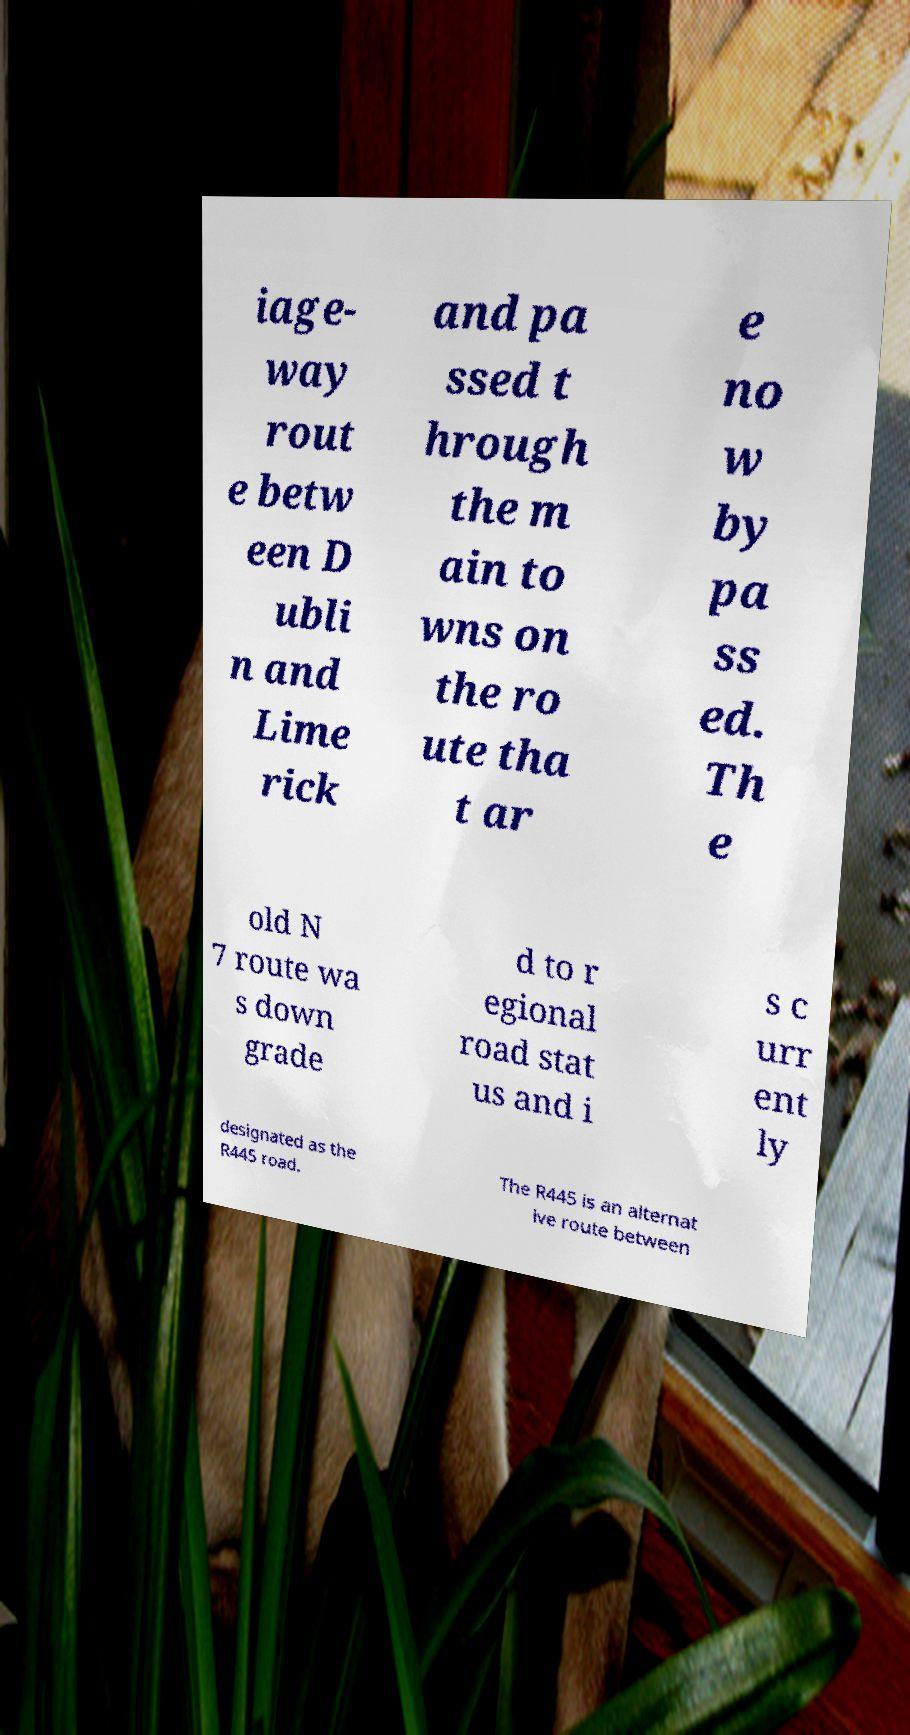Could you extract and type out the text from this image? iage- way rout e betw een D ubli n and Lime rick and pa ssed t hrough the m ain to wns on the ro ute tha t ar e no w by pa ss ed. Th e old N 7 route wa s down grade d to r egional road stat us and i s c urr ent ly designated as the R445 road. The R445 is an alternat ive route between 